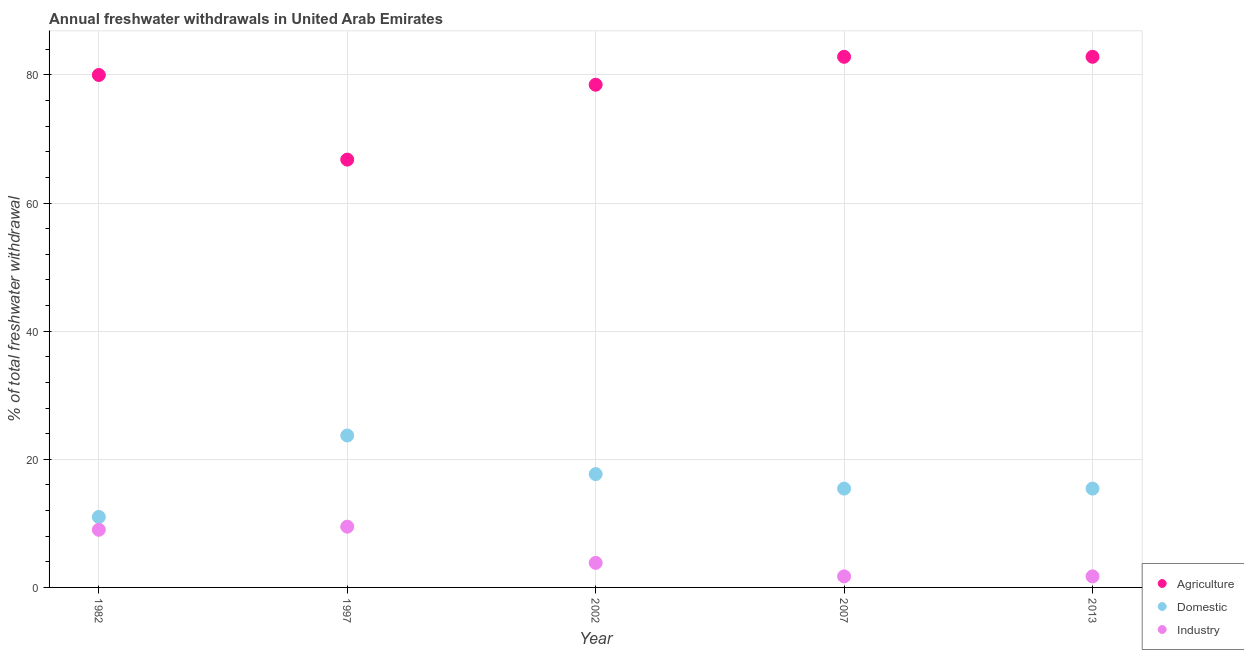How many different coloured dotlines are there?
Provide a succinct answer. 3. What is the percentage of freshwater withdrawal for agriculture in 2002?
Offer a terse response. 78.48. Across all years, what is the maximum percentage of freshwater withdrawal for domestic purposes?
Your response must be concise. 23.72. In which year was the percentage of freshwater withdrawal for domestic purposes minimum?
Provide a succinct answer. 1982. What is the total percentage of freshwater withdrawal for agriculture in the graph?
Make the answer very short. 390.95. What is the difference between the percentage of freshwater withdrawal for industry in 1982 and that in 2013?
Give a very brief answer. 7.27. What is the difference between the percentage of freshwater withdrawal for industry in 1997 and the percentage of freshwater withdrawal for agriculture in 2007?
Give a very brief answer. -73.35. What is the average percentage of freshwater withdrawal for industry per year?
Offer a very short reply. 5.15. In the year 2013, what is the difference between the percentage of freshwater withdrawal for agriculture and percentage of freshwater withdrawal for domestic purposes?
Offer a very short reply. 67.41. What is the ratio of the percentage of freshwater withdrawal for agriculture in 1982 to that in 1997?
Provide a succinct answer. 1.2. Is the percentage of freshwater withdrawal for agriculture in 1997 less than that in 2002?
Make the answer very short. Yes. What is the difference between the highest and the second highest percentage of freshwater withdrawal for industry?
Provide a succinct answer. 0.49. What is the difference between the highest and the lowest percentage of freshwater withdrawal for industry?
Offer a very short reply. 7.76. In how many years, is the percentage of freshwater withdrawal for domestic purposes greater than the average percentage of freshwater withdrawal for domestic purposes taken over all years?
Your response must be concise. 2. Is it the case that in every year, the sum of the percentage of freshwater withdrawal for agriculture and percentage of freshwater withdrawal for domestic purposes is greater than the percentage of freshwater withdrawal for industry?
Provide a short and direct response. Yes. Does the percentage of freshwater withdrawal for industry monotonically increase over the years?
Provide a short and direct response. No. What is the difference between two consecutive major ticks on the Y-axis?
Your response must be concise. 20. Where does the legend appear in the graph?
Offer a terse response. Bottom right. How many legend labels are there?
Keep it short and to the point. 3. What is the title of the graph?
Your answer should be very brief. Annual freshwater withdrawals in United Arab Emirates. What is the label or title of the X-axis?
Offer a terse response. Year. What is the label or title of the Y-axis?
Offer a terse response. % of total freshwater withdrawal. What is the % of total freshwater withdrawal in Agriculture in 1982?
Offer a very short reply. 80. What is the % of total freshwater withdrawal in Agriculture in 1997?
Ensure brevity in your answer.  66.79. What is the % of total freshwater withdrawal of Domestic in 1997?
Provide a succinct answer. 23.72. What is the % of total freshwater withdrawal in Industry in 1997?
Keep it short and to the point. 9.49. What is the % of total freshwater withdrawal of Agriculture in 2002?
Your answer should be very brief. 78.48. What is the % of total freshwater withdrawal in Domestic in 2002?
Offer a very short reply. 17.69. What is the % of total freshwater withdrawal in Industry in 2002?
Provide a succinct answer. 3.83. What is the % of total freshwater withdrawal of Agriculture in 2007?
Offer a terse response. 82.84. What is the % of total freshwater withdrawal of Domestic in 2007?
Provide a succinct answer. 15.43. What is the % of total freshwater withdrawal in Industry in 2007?
Your response must be concise. 1.73. What is the % of total freshwater withdrawal of Agriculture in 2013?
Provide a succinct answer. 82.84. What is the % of total freshwater withdrawal of Domestic in 2013?
Give a very brief answer. 15.43. What is the % of total freshwater withdrawal in Industry in 2013?
Ensure brevity in your answer.  1.73. Across all years, what is the maximum % of total freshwater withdrawal in Agriculture?
Offer a very short reply. 82.84. Across all years, what is the maximum % of total freshwater withdrawal in Domestic?
Make the answer very short. 23.72. Across all years, what is the maximum % of total freshwater withdrawal of Industry?
Give a very brief answer. 9.49. Across all years, what is the minimum % of total freshwater withdrawal of Agriculture?
Keep it short and to the point. 66.79. Across all years, what is the minimum % of total freshwater withdrawal in Domestic?
Your response must be concise. 11. Across all years, what is the minimum % of total freshwater withdrawal in Industry?
Ensure brevity in your answer.  1.73. What is the total % of total freshwater withdrawal in Agriculture in the graph?
Make the answer very short. 390.95. What is the total % of total freshwater withdrawal in Domestic in the graph?
Provide a short and direct response. 83.27. What is the total % of total freshwater withdrawal in Industry in the graph?
Give a very brief answer. 25.77. What is the difference between the % of total freshwater withdrawal in Agriculture in 1982 and that in 1997?
Your response must be concise. 13.21. What is the difference between the % of total freshwater withdrawal of Domestic in 1982 and that in 1997?
Give a very brief answer. -12.72. What is the difference between the % of total freshwater withdrawal of Industry in 1982 and that in 1997?
Ensure brevity in your answer.  -0.49. What is the difference between the % of total freshwater withdrawal in Agriculture in 1982 and that in 2002?
Your response must be concise. 1.52. What is the difference between the % of total freshwater withdrawal in Domestic in 1982 and that in 2002?
Provide a short and direct response. -6.69. What is the difference between the % of total freshwater withdrawal in Industry in 1982 and that in 2002?
Give a very brief answer. 5.17. What is the difference between the % of total freshwater withdrawal of Agriculture in 1982 and that in 2007?
Make the answer very short. -2.84. What is the difference between the % of total freshwater withdrawal in Domestic in 1982 and that in 2007?
Your response must be concise. -4.43. What is the difference between the % of total freshwater withdrawal in Industry in 1982 and that in 2007?
Ensure brevity in your answer.  7.27. What is the difference between the % of total freshwater withdrawal of Agriculture in 1982 and that in 2013?
Your answer should be compact. -2.84. What is the difference between the % of total freshwater withdrawal of Domestic in 1982 and that in 2013?
Your response must be concise. -4.43. What is the difference between the % of total freshwater withdrawal of Industry in 1982 and that in 2013?
Your answer should be very brief. 7.27. What is the difference between the % of total freshwater withdrawal of Agriculture in 1997 and that in 2002?
Ensure brevity in your answer.  -11.69. What is the difference between the % of total freshwater withdrawal of Domestic in 1997 and that in 2002?
Your answer should be compact. 6.03. What is the difference between the % of total freshwater withdrawal in Industry in 1997 and that in 2002?
Keep it short and to the point. 5.66. What is the difference between the % of total freshwater withdrawal of Agriculture in 1997 and that in 2007?
Offer a very short reply. -16.05. What is the difference between the % of total freshwater withdrawal of Domestic in 1997 and that in 2007?
Offer a terse response. 8.29. What is the difference between the % of total freshwater withdrawal in Industry in 1997 and that in 2007?
Keep it short and to the point. 7.76. What is the difference between the % of total freshwater withdrawal of Agriculture in 1997 and that in 2013?
Ensure brevity in your answer.  -16.05. What is the difference between the % of total freshwater withdrawal of Domestic in 1997 and that in 2013?
Make the answer very short. 8.29. What is the difference between the % of total freshwater withdrawal in Industry in 1997 and that in 2013?
Make the answer very short. 7.76. What is the difference between the % of total freshwater withdrawal of Agriculture in 2002 and that in 2007?
Your answer should be very brief. -4.36. What is the difference between the % of total freshwater withdrawal of Domestic in 2002 and that in 2007?
Offer a very short reply. 2.26. What is the difference between the % of total freshwater withdrawal of Industry in 2002 and that in 2007?
Provide a succinct answer. 2.11. What is the difference between the % of total freshwater withdrawal of Agriculture in 2002 and that in 2013?
Offer a terse response. -4.36. What is the difference between the % of total freshwater withdrawal in Domestic in 2002 and that in 2013?
Offer a terse response. 2.26. What is the difference between the % of total freshwater withdrawal in Industry in 2002 and that in 2013?
Offer a very short reply. 2.11. What is the difference between the % of total freshwater withdrawal of Industry in 2007 and that in 2013?
Provide a short and direct response. 0. What is the difference between the % of total freshwater withdrawal in Agriculture in 1982 and the % of total freshwater withdrawal in Domestic in 1997?
Ensure brevity in your answer.  56.28. What is the difference between the % of total freshwater withdrawal in Agriculture in 1982 and the % of total freshwater withdrawal in Industry in 1997?
Your answer should be very brief. 70.51. What is the difference between the % of total freshwater withdrawal of Domestic in 1982 and the % of total freshwater withdrawal of Industry in 1997?
Give a very brief answer. 1.51. What is the difference between the % of total freshwater withdrawal of Agriculture in 1982 and the % of total freshwater withdrawal of Domestic in 2002?
Your response must be concise. 62.31. What is the difference between the % of total freshwater withdrawal in Agriculture in 1982 and the % of total freshwater withdrawal in Industry in 2002?
Keep it short and to the point. 76.17. What is the difference between the % of total freshwater withdrawal in Domestic in 1982 and the % of total freshwater withdrawal in Industry in 2002?
Provide a succinct answer. 7.17. What is the difference between the % of total freshwater withdrawal of Agriculture in 1982 and the % of total freshwater withdrawal of Domestic in 2007?
Your answer should be compact. 64.57. What is the difference between the % of total freshwater withdrawal in Agriculture in 1982 and the % of total freshwater withdrawal in Industry in 2007?
Keep it short and to the point. 78.27. What is the difference between the % of total freshwater withdrawal of Domestic in 1982 and the % of total freshwater withdrawal of Industry in 2007?
Your answer should be very brief. 9.27. What is the difference between the % of total freshwater withdrawal in Agriculture in 1982 and the % of total freshwater withdrawal in Domestic in 2013?
Provide a short and direct response. 64.57. What is the difference between the % of total freshwater withdrawal in Agriculture in 1982 and the % of total freshwater withdrawal in Industry in 2013?
Provide a short and direct response. 78.27. What is the difference between the % of total freshwater withdrawal in Domestic in 1982 and the % of total freshwater withdrawal in Industry in 2013?
Offer a very short reply. 9.27. What is the difference between the % of total freshwater withdrawal of Agriculture in 1997 and the % of total freshwater withdrawal of Domestic in 2002?
Ensure brevity in your answer.  49.1. What is the difference between the % of total freshwater withdrawal in Agriculture in 1997 and the % of total freshwater withdrawal in Industry in 2002?
Make the answer very short. 62.96. What is the difference between the % of total freshwater withdrawal of Domestic in 1997 and the % of total freshwater withdrawal of Industry in 2002?
Your answer should be compact. 19.89. What is the difference between the % of total freshwater withdrawal in Agriculture in 1997 and the % of total freshwater withdrawal in Domestic in 2007?
Provide a succinct answer. 51.36. What is the difference between the % of total freshwater withdrawal of Agriculture in 1997 and the % of total freshwater withdrawal of Industry in 2007?
Offer a terse response. 65.06. What is the difference between the % of total freshwater withdrawal in Domestic in 1997 and the % of total freshwater withdrawal in Industry in 2007?
Your answer should be very brief. 21.99. What is the difference between the % of total freshwater withdrawal in Agriculture in 1997 and the % of total freshwater withdrawal in Domestic in 2013?
Make the answer very short. 51.36. What is the difference between the % of total freshwater withdrawal in Agriculture in 1997 and the % of total freshwater withdrawal in Industry in 2013?
Give a very brief answer. 65.06. What is the difference between the % of total freshwater withdrawal in Domestic in 1997 and the % of total freshwater withdrawal in Industry in 2013?
Make the answer very short. 21.99. What is the difference between the % of total freshwater withdrawal of Agriculture in 2002 and the % of total freshwater withdrawal of Domestic in 2007?
Provide a short and direct response. 63.05. What is the difference between the % of total freshwater withdrawal in Agriculture in 2002 and the % of total freshwater withdrawal in Industry in 2007?
Keep it short and to the point. 76.75. What is the difference between the % of total freshwater withdrawal in Domestic in 2002 and the % of total freshwater withdrawal in Industry in 2007?
Your response must be concise. 15.96. What is the difference between the % of total freshwater withdrawal of Agriculture in 2002 and the % of total freshwater withdrawal of Domestic in 2013?
Your response must be concise. 63.05. What is the difference between the % of total freshwater withdrawal of Agriculture in 2002 and the % of total freshwater withdrawal of Industry in 2013?
Offer a very short reply. 76.75. What is the difference between the % of total freshwater withdrawal in Domestic in 2002 and the % of total freshwater withdrawal in Industry in 2013?
Your answer should be compact. 15.96. What is the difference between the % of total freshwater withdrawal in Agriculture in 2007 and the % of total freshwater withdrawal in Domestic in 2013?
Provide a succinct answer. 67.41. What is the difference between the % of total freshwater withdrawal of Agriculture in 2007 and the % of total freshwater withdrawal of Industry in 2013?
Provide a succinct answer. 81.11. What is the difference between the % of total freshwater withdrawal in Domestic in 2007 and the % of total freshwater withdrawal in Industry in 2013?
Give a very brief answer. 13.7. What is the average % of total freshwater withdrawal of Agriculture per year?
Keep it short and to the point. 78.19. What is the average % of total freshwater withdrawal of Domestic per year?
Give a very brief answer. 16.65. What is the average % of total freshwater withdrawal of Industry per year?
Provide a succinct answer. 5.15. In the year 1982, what is the difference between the % of total freshwater withdrawal of Agriculture and % of total freshwater withdrawal of Domestic?
Your answer should be compact. 69. In the year 1982, what is the difference between the % of total freshwater withdrawal in Agriculture and % of total freshwater withdrawal in Industry?
Your answer should be very brief. 71. In the year 1997, what is the difference between the % of total freshwater withdrawal of Agriculture and % of total freshwater withdrawal of Domestic?
Ensure brevity in your answer.  43.07. In the year 1997, what is the difference between the % of total freshwater withdrawal of Agriculture and % of total freshwater withdrawal of Industry?
Keep it short and to the point. 57.3. In the year 1997, what is the difference between the % of total freshwater withdrawal of Domestic and % of total freshwater withdrawal of Industry?
Provide a short and direct response. 14.23. In the year 2002, what is the difference between the % of total freshwater withdrawal in Agriculture and % of total freshwater withdrawal in Domestic?
Keep it short and to the point. 60.79. In the year 2002, what is the difference between the % of total freshwater withdrawal of Agriculture and % of total freshwater withdrawal of Industry?
Your answer should be compact. 74.65. In the year 2002, what is the difference between the % of total freshwater withdrawal in Domestic and % of total freshwater withdrawal in Industry?
Provide a succinct answer. 13.86. In the year 2007, what is the difference between the % of total freshwater withdrawal of Agriculture and % of total freshwater withdrawal of Domestic?
Give a very brief answer. 67.41. In the year 2007, what is the difference between the % of total freshwater withdrawal in Agriculture and % of total freshwater withdrawal in Industry?
Give a very brief answer. 81.11. In the year 2007, what is the difference between the % of total freshwater withdrawal of Domestic and % of total freshwater withdrawal of Industry?
Offer a terse response. 13.7. In the year 2013, what is the difference between the % of total freshwater withdrawal of Agriculture and % of total freshwater withdrawal of Domestic?
Give a very brief answer. 67.41. In the year 2013, what is the difference between the % of total freshwater withdrawal of Agriculture and % of total freshwater withdrawal of Industry?
Keep it short and to the point. 81.11. In the year 2013, what is the difference between the % of total freshwater withdrawal in Domestic and % of total freshwater withdrawal in Industry?
Give a very brief answer. 13.7. What is the ratio of the % of total freshwater withdrawal in Agriculture in 1982 to that in 1997?
Your answer should be compact. 1.2. What is the ratio of the % of total freshwater withdrawal of Domestic in 1982 to that in 1997?
Offer a very short reply. 0.46. What is the ratio of the % of total freshwater withdrawal in Industry in 1982 to that in 1997?
Provide a succinct answer. 0.95. What is the ratio of the % of total freshwater withdrawal of Agriculture in 1982 to that in 2002?
Give a very brief answer. 1.02. What is the ratio of the % of total freshwater withdrawal of Domestic in 1982 to that in 2002?
Offer a terse response. 0.62. What is the ratio of the % of total freshwater withdrawal in Industry in 1982 to that in 2002?
Offer a terse response. 2.35. What is the ratio of the % of total freshwater withdrawal of Agriculture in 1982 to that in 2007?
Give a very brief answer. 0.97. What is the ratio of the % of total freshwater withdrawal in Domestic in 1982 to that in 2007?
Your response must be concise. 0.71. What is the ratio of the % of total freshwater withdrawal in Industry in 1982 to that in 2007?
Make the answer very short. 5.21. What is the ratio of the % of total freshwater withdrawal of Agriculture in 1982 to that in 2013?
Make the answer very short. 0.97. What is the ratio of the % of total freshwater withdrawal of Domestic in 1982 to that in 2013?
Your response must be concise. 0.71. What is the ratio of the % of total freshwater withdrawal in Industry in 1982 to that in 2013?
Offer a very short reply. 5.21. What is the ratio of the % of total freshwater withdrawal in Agriculture in 1997 to that in 2002?
Give a very brief answer. 0.85. What is the ratio of the % of total freshwater withdrawal of Domestic in 1997 to that in 2002?
Give a very brief answer. 1.34. What is the ratio of the % of total freshwater withdrawal of Industry in 1997 to that in 2002?
Your response must be concise. 2.48. What is the ratio of the % of total freshwater withdrawal of Agriculture in 1997 to that in 2007?
Your answer should be very brief. 0.81. What is the ratio of the % of total freshwater withdrawal in Domestic in 1997 to that in 2007?
Provide a short and direct response. 1.54. What is the ratio of the % of total freshwater withdrawal of Industry in 1997 to that in 2007?
Your answer should be very brief. 5.5. What is the ratio of the % of total freshwater withdrawal in Agriculture in 1997 to that in 2013?
Offer a terse response. 0.81. What is the ratio of the % of total freshwater withdrawal of Domestic in 1997 to that in 2013?
Keep it short and to the point. 1.54. What is the ratio of the % of total freshwater withdrawal in Industry in 1997 to that in 2013?
Provide a succinct answer. 5.5. What is the ratio of the % of total freshwater withdrawal of Domestic in 2002 to that in 2007?
Ensure brevity in your answer.  1.15. What is the ratio of the % of total freshwater withdrawal of Industry in 2002 to that in 2007?
Your response must be concise. 2.22. What is the ratio of the % of total freshwater withdrawal of Domestic in 2002 to that in 2013?
Offer a very short reply. 1.15. What is the ratio of the % of total freshwater withdrawal in Industry in 2002 to that in 2013?
Provide a short and direct response. 2.22. What is the ratio of the % of total freshwater withdrawal in Industry in 2007 to that in 2013?
Offer a very short reply. 1. What is the difference between the highest and the second highest % of total freshwater withdrawal of Domestic?
Your answer should be very brief. 6.03. What is the difference between the highest and the second highest % of total freshwater withdrawal in Industry?
Keep it short and to the point. 0.49. What is the difference between the highest and the lowest % of total freshwater withdrawal of Agriculture?
Offer a very short reply. 16.05. What is the difference between the highest and the lowest % of total freshwater withdrawal in Domestic?
Make the answer very short. 12.72. What is the difference between the highest and the lowest % of total freshwater withdrawal of Industry?
Your answer should be very brief. 7.76. 